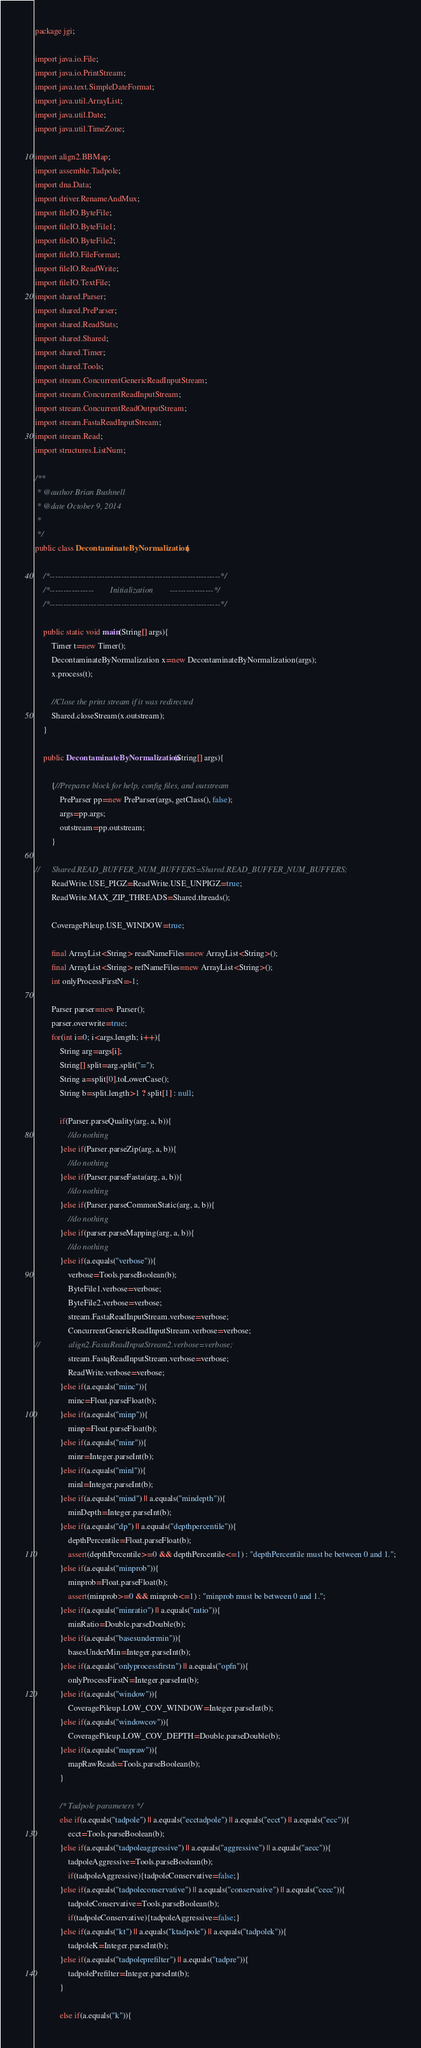<code> <loc_0><loc_0><loc_500><loc_500><_Java_>package jgi;

import java.io.File;
import java.io.PrintStream;
import java.text.SimpleDateFormat;
import java.util.ArrayList;
import java.util.Date;
import java.util.TimeZone;

import align2.BBMap;
import assemble.Tadpole;
import dna.Data;
import driver.RenameAndMux;
import fileIO.ByteFile;
import fileIO.ByteFile1;
import fileIO.ByteFile2;
import fileIO.FileFormat;
import fileIO.ReadWrite;
import fileIO.TextFile;
import shared.Parser;
import shared.PreParser;
import shared.ReadStats;
import shared.Shared;
import shared.Timer;
import shared.Tools;
import stream.ConcurrentGenericReadInputStream;
import stream.ConcurrentReadInputStream;
import stream.ConcurrentReadOutputStream;
import stream.FastaReadInputStream;
import stream.Read;
import structures.ListNum;

/**
 * @author Brian Bushnell
 * @date October 9, 2014
 *
 */
public class DecontaminateByNormalization {
	
	/*--------------------------------------------------------------*/
	/*----------------        Initialization        ----------------*/
	/*--------------------------------------------------------------*/

	public static void main(String[] args){
		Timer t=new Timer();
		DecontaminateByNormalization x=new DecontaminateByNormalization(args);
		x.process(t);
		
		//Close the print stream if it was redirected
		Shared.closeStream(x.outstream);
	}
	
	public DecontaminateByNormalization(String[] args){
		
		{//Preparse block for help, config files, and outstream
			PreParser pp=new PreParser(args, getClass(), false);
			args=pp.args;
			outstream=pp.outstream;
		}
		
//		Shared.READ_BUFFER_NUM_BUFFERS=Shared.READ_BUFFER_NUM_BUFFERS;
		ReadWrite.USE_PIGZ=ReadWrite.USE_UNPIGZ=true;
		ReadWrite.MAX_ZIP_THREADS=Shared.threads();
		
		CoveragePileup.USE_WINDOW=true;

		final ArrayList<String> readNameFiles=new ArrayList<String>();
		final ArrayList<String> refNameFiles=new ArrayList<String>();
		int onlyProcessFirstN=-1;
		
		Parser parser=new Parser();
		parser.overwrite=true;
		for(int i=0; i<args.length; i++){
			String arg=args[i];
			String[] split=arg.split("=");
			String a=split[0].toLowerCase();
			String b=split.length>1 ? split[1] : null;
			
			if(Parser.parseQuality(arg, a, b)){
				//do nothing
			}else if(Parser.parseZip(arg, a, b)){
				//do nothing
			}else if(Parser.parseFasta(arg, a, b)){
				//do nothing
			}else if(Parser.parseCommonStatic(arg, a, b)){
				//do nothing
			}else if(parser.parseMapping(arg, a, b)){
				//do nothing
			}else if(a.equals("verbose")){
				verbose=Tools.parseBoolean(b);
				ByteFile1.verbose=verbose;
				ByteFile2.verbose=verbose;
				stream.FastaReadInputStream.verbose=verbose;
				ConcurrentGenericReadInputStream.verbose=verbose;
//				align2.FastaReadInputStream2.verbose=verbose;
				stream.FastqReadInputStream.verbose=verbose;
				ReadWrite.verbose=verbose;
			}else if(a.equals("minc")){
				minc=Float.parseFloat(b);
			}else if(a.equals("minp")){
				minp=Float.parseFloat(b);
			}else if(a.equals("minr")){
				minr=Integer.parseInt(b);
			}else if(a.equals("minl")){
				minl=Integer.parseInt(b);
			}else if(a.equals("mind") || a.equals("mindepth")){
				minDepth=Integer.parseInt(b);
			}else if(a.equals("dp") || a.equals("depthpercentile")){
				depthPercentile=Float.parseFloat(b);
				assert(depthPercentile>=0 && depthPercentile<=1) : "depthPercentile must be between 0 and 1.";
			}else if(a.equals("minprob")){
				minprob=Float.parseFloat(b);
				assert(minprob>=0 && minprob<=1) : "minprob must be between 0 and 1.";
			}else if(a.equals("minratio") || a.equals("ratio")){
				minRatio=Double.parseDouble(b);
			}else if(a.equals("basesundermin")){
				basesUnderMin=Integer.parseInt(b);
			}else if(a.equals("onlyprocessfirstn") || a.equals("opfn")){
				onlyProcessFirstN=Integer.parseInt(b);
			}else if(a.equals("window")){
				CoveragePileup.LOW_COV_WINDOW=Integer.parseInt(b);
			}else if(a.equals("windowcov")){
				CoveragePileup.LOW_COV_DEPTH=Double.parseDouble(b);
			}else if(a.equals("mapraw")){
				mapRawReads=Tools.parseBoolean(b);
			}
			
			/* Tadpole parameters */
			else if(a.equals("tadpole") || a.equals("ecctadpole") || a.equals("ecct") || a.equals("ecc")){
				ecct=Tools.parseBoolean(b);
			}else if(a.equals("tadpoleaggressive") || a.equals("aggressive") || a.equals("aecc")){
				tadpoleAggressive=Tools.parseBoolean(b);
				if(tadpoleAggressive){tadpoleConservative=false;}
			}else if(a.equals("tadpoleconservative") || a.equals("conservative") || a.equals("cecc")){
				tadpoleConservative=Tools.parseBoolean(b);
				if(tadpoleConservative){tadpoleAggressive=false;}
			}else if(a.equals("kt") || a.equals("ktadpole") || a.equals("tadpolek")){
				tadpoleK=Integer.parseInt(b);
			}else if(a.equals("tadpoleprefilter") || a.equals("tadpre")){
				tadpolePrefilter=Integer.parseInt(b);
			}
			
			else if(a.equals("k")){</code> 